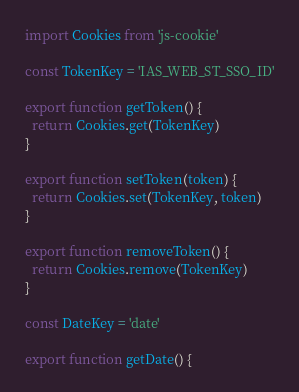Convert code to text. <code><loc_0><loc_0><loc_500><loc_500><_JavaScript_>import Cookies from 'js-cookie'

const TokenKey = 'IAS_WEB_ST_SSO_ID'

export function getToken() {
  return Cookies.get(TokenKey)
}

export function setToken(token) {
  return Cookies.set(TokenKey, token)
}

export function removeToken() {
  return Cookies.remove(TokenKey)
}

const DateKey = 'date'

export function getDate() {</code> 